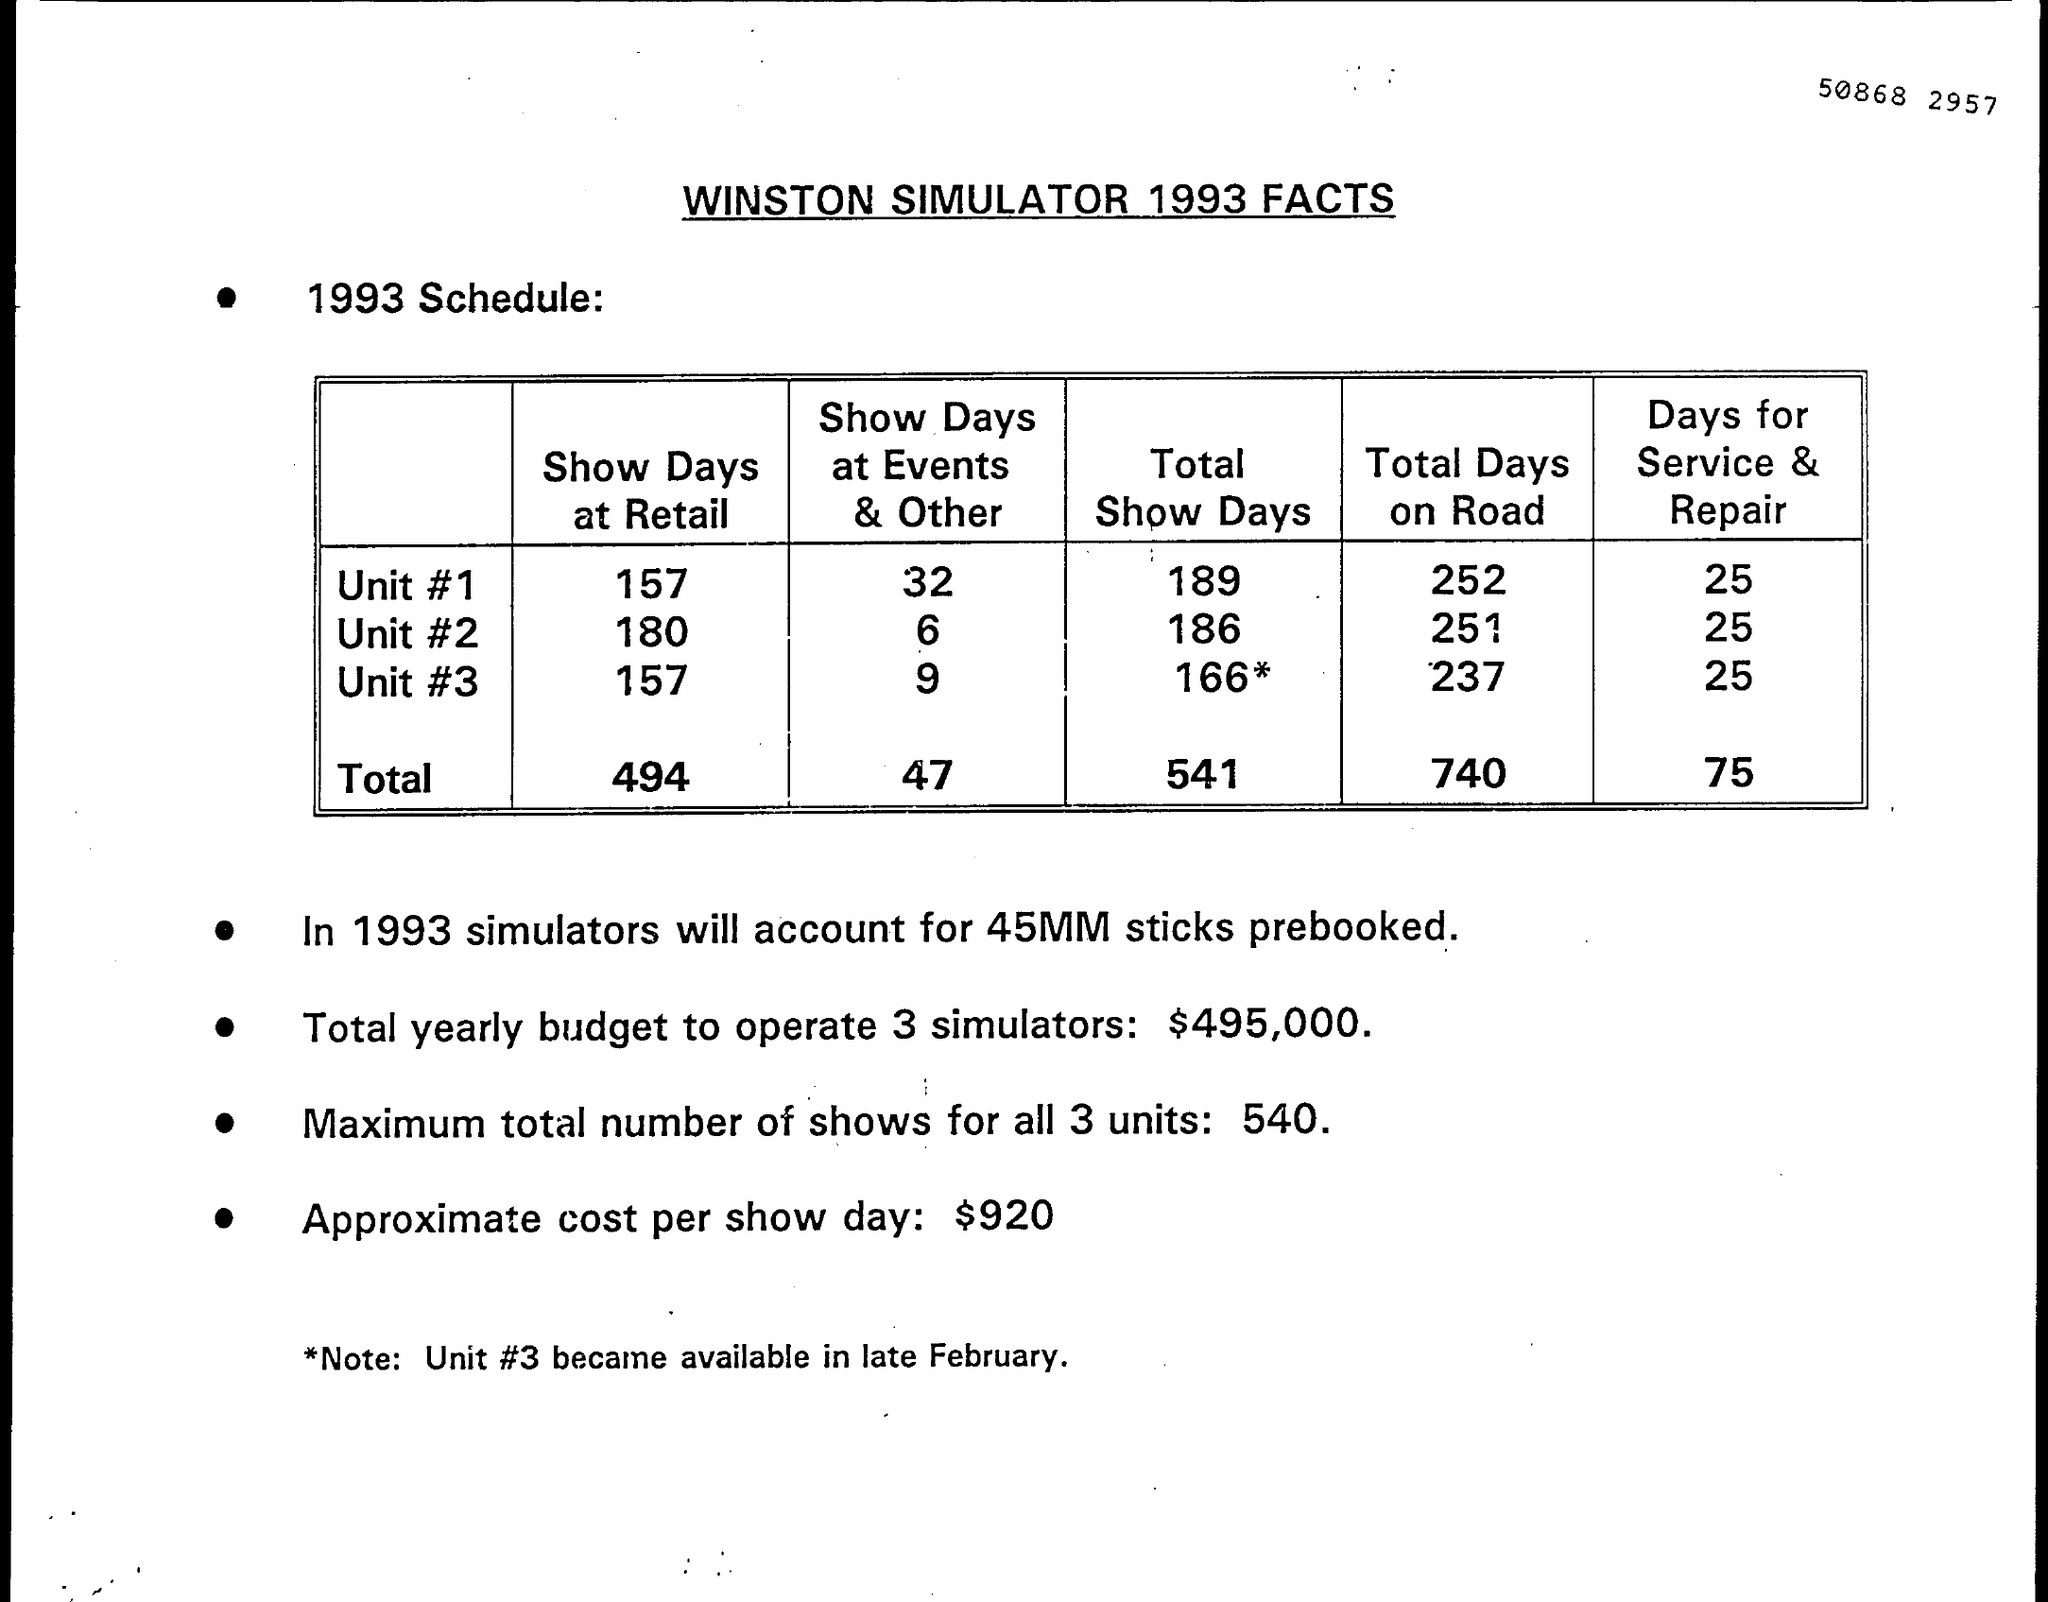Indicate a few pertinent items in this graphic. The title of the document is WINSTON SIMULATOR 1993 FACTS. The approximate cost per show day is approximately $920. The pre-booking of sticks is 45 million sticks. The availability of Unit #3 became known in late February. The total yearly budget required to operate three simulators is estimated to be $495,000. 